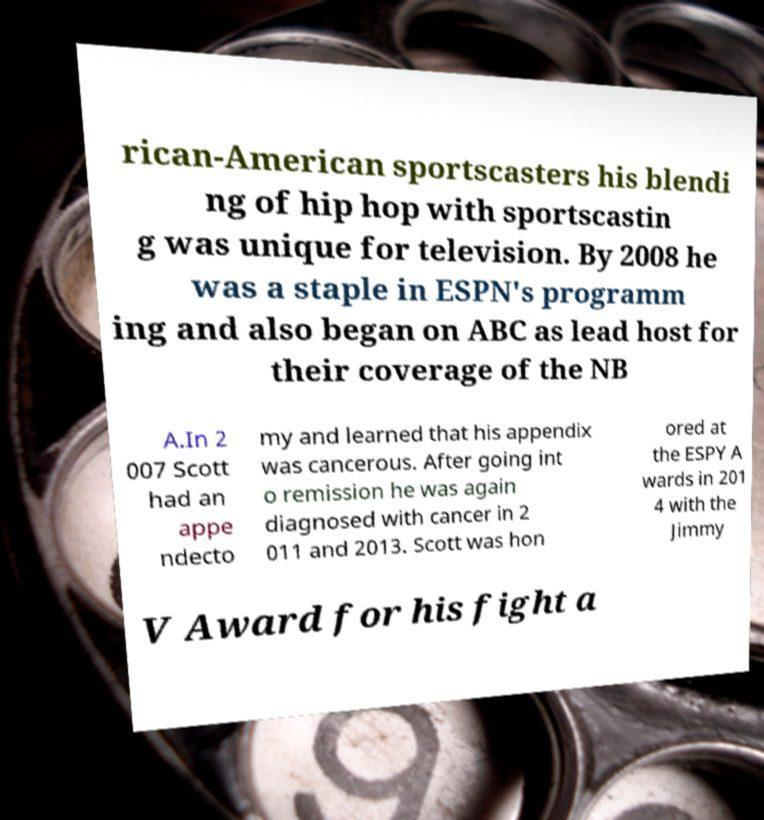What messages or text are displayed in this image? I need them in a readable, typed format. rican-American sportscasters his blendi ng of hip hop with sportscastin g was unique for television. By 2008 he was a staple in ESPN's programm ing and also began on ABC as lead host for their coverage of the NB A.In 2 007 Scott had an appe ndecto my and learned that his appendix was cancerous. After going int o remission he was again diagnosed with cancer in 2 011 and 2013. Scott was hon ored at the ESPY A wards in 201 4 with the Jimmy V Award for his fight a 